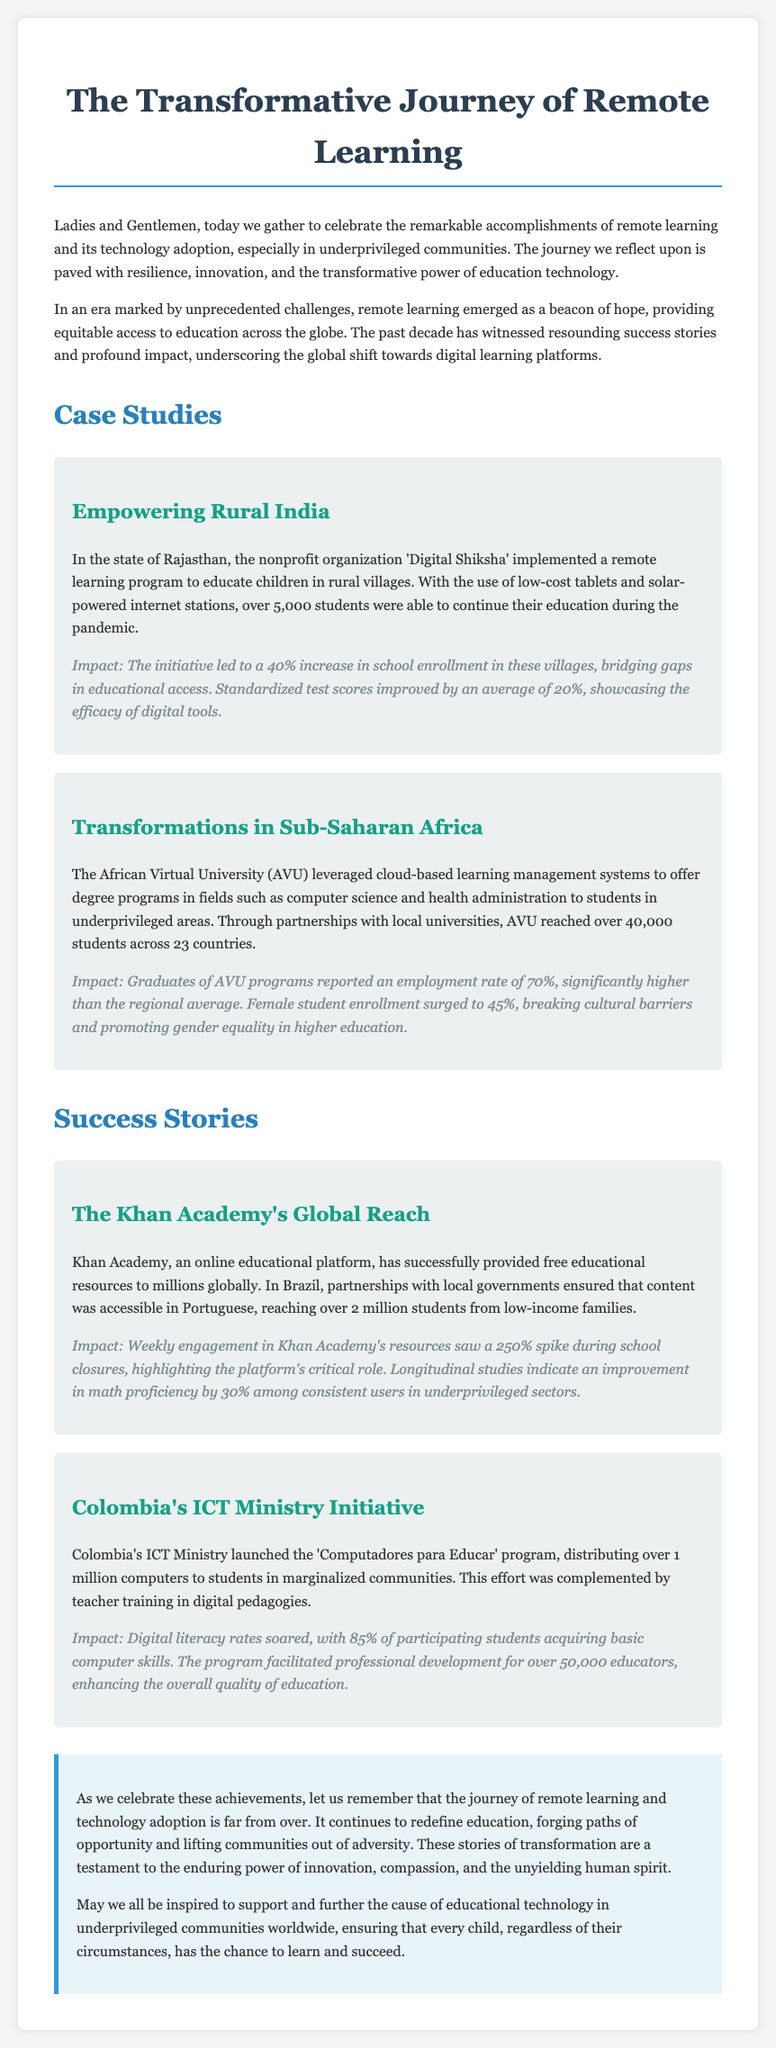What is the title of the eulogy? The title of the eulogy is shown prominently at the top of the document.
Answer: The Transformative Journey of Remote Learning Which organization implemented a remote learning program in rural India? The document specifies the nonprofit organization that carried out the initiative in Rajasthan, India.
Answer: Digital Shiksha How many students in Rajasthan benefited from the remote learning program? The document states the number of students who were able to continue their education through the initiative.
Answer: 5,000 What was the percentage increase in school enrollment due to the initiative in rural India? The document mentions the increase in school enrollment as a specific impact of the program.
Answer: 40% What is the employment rate reported by graduates of the African Virtual University programs? The document provides information regarding the employment outcomes for graduates of the AVU programs.
Answer: 70% How many students did Khan Academy reach in Brazil? The document indicates the number of students who accessed Khan Academy's resources in Brazil, facilitated through local partnerships.
Answer: 2 million What aspect of education did Colombia's ICT Ministry program focus on improving? The document highlights the key objective of the 'Computadores para Educar' program launched by Colombia’s ICT Ministry.
Answer: Digital literacy What is the reported improvement in math proficiency among consistent users of Khan Academy? The document provides metrics on the educational outcomes for users of the platform in underprivileged sectors.
Answer: 30% What was the impact on teacher training due to the 'Computadores para Educar' program? The document states the effect of the program on professional development for educators.
Answer: 50,000 educators 